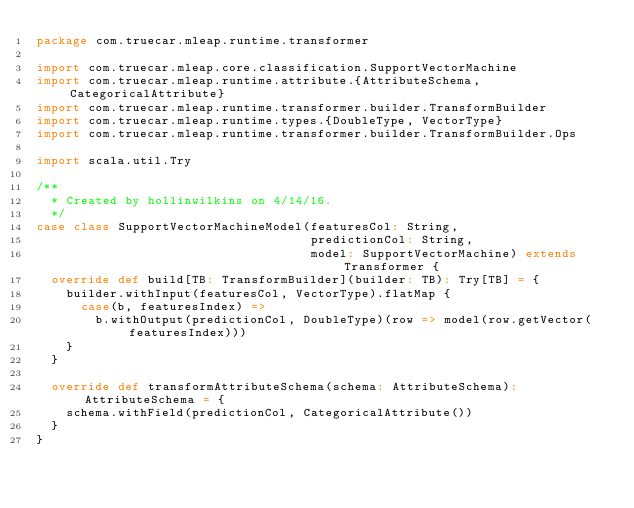Convert code to text. <code><loc_0><loc_0><loc_500><loc_500><_Scala_>package com.truecar.mleap.runtime.transformer

import com.truecar.mleap.core.classification.SupportVectorMachine
import com.truecar.mleap.runtime.attribute.{AttributeSchema, CategoricalAttribute}
import com.truecar.mleap.runtime.transformer.builder.TransformBuilder
import com.truecar.mleap.runtime.types.{DoubleType, VectorType}
import com.truecar.mleap.runtime.transformer.builder.TransformBuilder.Ops

import scala.util.Try

/**
  * Created by hollinwilkins on 4/14/16.
  */
case class SupportVectorMachineModel(featuresCol: String,
                                     predictionCol: String,
                                     model: SupportVectorMachine) extends Transformer {
  override def build[TB: TransformBuilder](builder: TB): Try[TB] = {
    builder.withInput(featuresCol, VectorType).flatMap {
      case(b, featuresIndex) =>
        b.withOutput(predictionCol, DoubleType)(row => model(row.getVector(featuresIndex)))
    }
  }

  override def transformAttributeSchema(schema: AttributeSchema): AttributeSchema = {
    schema.withField(predictionCol, CategoricalAttribute())
  }
}
</code> 